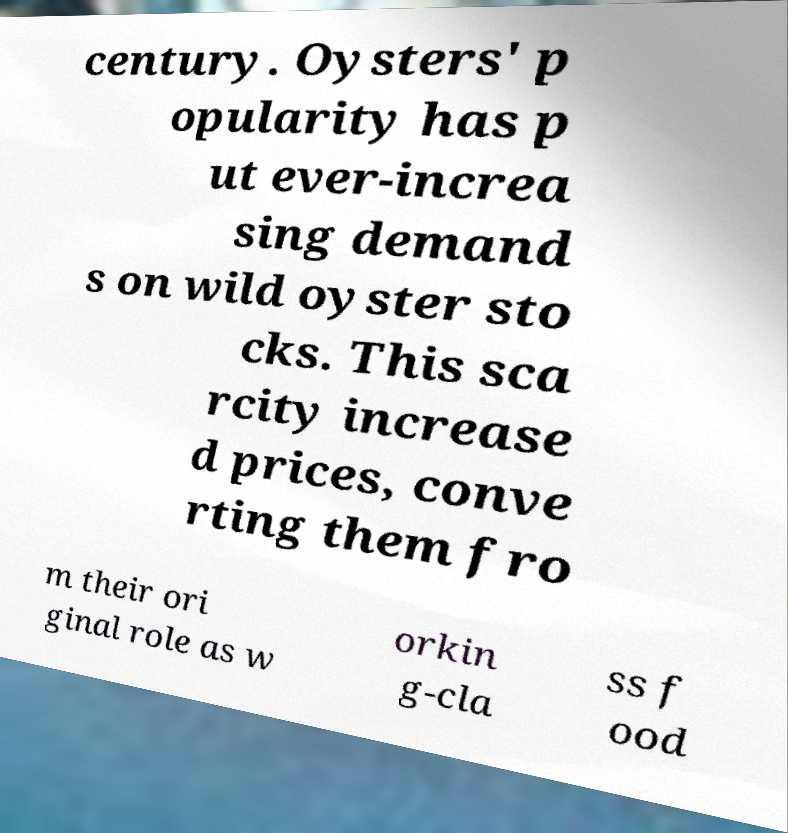Please read and relay the text visible in this image. What does it say? century. Oysters' p opularity has p ut ever-increa sing demand s on wild oyster sto cks. This sca rcity increase d prices, conve rting them fro m their ori ginal role as w orkin g-cla ss f ood 